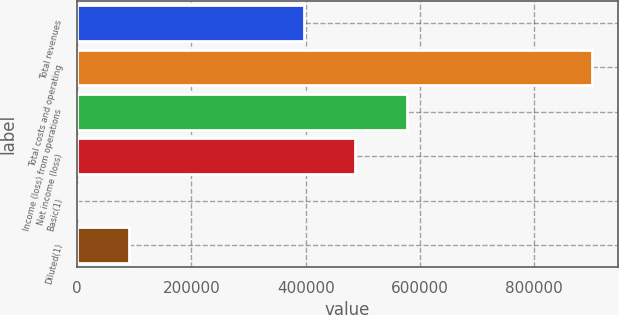<chart> <loc_0><loc_0><loc_500><loc_500><bar_chart><fcel>Total revenues<fcel>Total costs and operating<fcel>Income (loss) from operations<fcel>Net income (loss)<fcel>Basic(1)<fcel>Diluted(1)<nl><fcel>396589<fcel>902220<fcel>577032<fcel>486811<fcel>2.57<fcel>90224.3<nl></chart> 